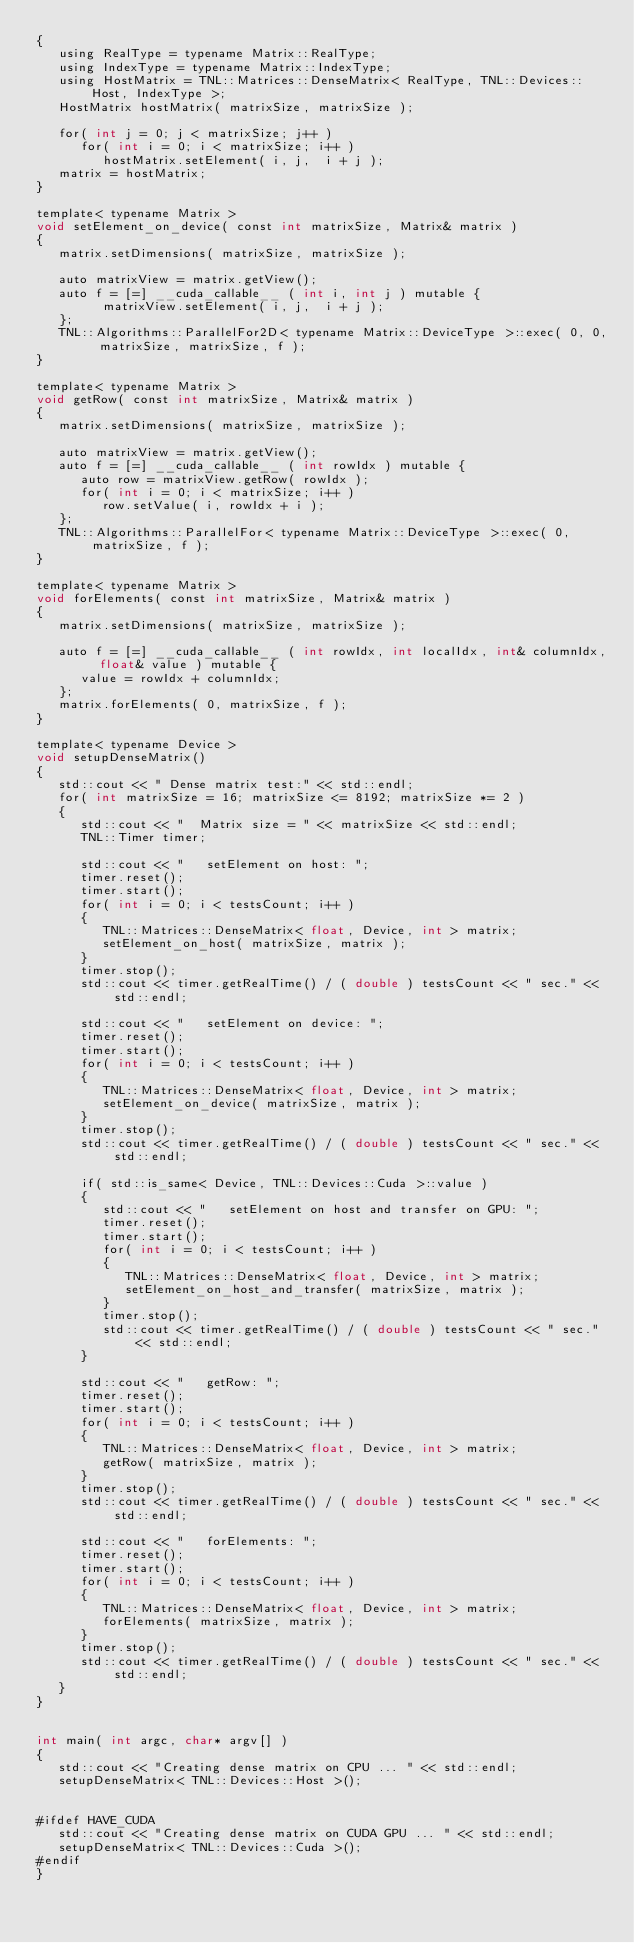<code> <loc_0><loc_0><loc_500><loc_500><_Cuda_>{
   using RealType = typename Matrix::RealType;
   using IndexType = typename Matrix::IndexType;
   using HostMatrix = TNL::Matrices::DenseMatrix< RealType, TNL::Devices::Host, IndexType >;
   HostMatrix hostMatrix( matrixSize, matrixSize );

   for( int j = 0; j < matrixSize; j++ )
      for( int i = 0; i < matrixSize; i++ )
         hostMatrix.setElement( i, j,  i + j );
   matrix = hostMatrix;
}

template< typename Matrix >
void setElement_on_device( const int matrixSize, Matrix& matrix )
{
   matrix.setDimensions( matrixSize, matrixSize );

   auto matrixView = matrix.getView();
   auto f = [=] __cuda_callable__ ( int i, int j ) mutable {
         matrixView.setElement( i, j,  i + j );
   };
   TNL::Algorithms::ParallelFor2D< typename Matrix::DeviceType >::exec( 0, 0, matrixSize, matrixSize, f );
}

template< typename Matrix >
void getRow( const int matrixSize, Matrix& matrix )
{
   matrix.setDimensions( matrixSize, matrixSize );

   auto matrixView = matrix.getView();
   auto f = [=] __cuda_callable__ ( int rowIdx ) mutable {
      auto row = matrixView.getRow( rowIdx );
      for( int i = 0; i < matrixSize; i++ )
         row.setValue( i, rowIdx + i );
   };
   TNL::Algorithms::ParallelFor< typename Matrix::DeviceType >::exec( 0, matrixSize, f );
}

template< typename Matrix >
void forElements( const int matrixSize, Matrix& matrix )
{
   matrix.setDimensions( matrixSize, matrixSize );

   auto f = [=] __cuda_callable__ ( int rowIdx, int localIdx, int& columnIdx, float& value ) mutable {
      value = rowIdx + columnIdx;
   };
   matrix.forElements( 0, matrixSize, f );
}

template< typename Device >
void setupDenseMatrix()
{
   std::cout << " Dense matrix test:" << std::endl;
   for( int matrixSize = 16; matrixSize <= 8192; matrixSize *= 2 )
   {
      std::cout << "  Matrix size = " << matrixSize << std::endl;
      TNL::Timer timer;

      std::cout << "   setElement on host: ";
      timer.reset();
      timer.start();
      for( int i = 0; i < testsCount; i++ )
      {
         TNL::Matrices::DenseMatrix< float, Device, int > matrix;
         setElement_on_host( matrixSize, matrix );
      }
      timer.stop();
      std::cout << timer.getRealTime() / ( double ) testsCount << " sec." << std::endl;

      std::cout << "   setElement on device: ";
      timer.reset();
      timer.start();
      for( int i = 0; i < testsCount; i++ )
      {
         TNL::Matrices::DenseMatrix< float, Device, int > matrix;
         setElement_on_device( matrixSize, matrix );
      }
      timer.stop();
      std::cout << timer.getRealTime() / ( double ) testsCount << " sec." << std::endl;

      if( std::is_same< Device, TNL::Devices::Cuda >::value )
      {
         std::cout << "   setElement on host and transfer on GPU: ";
         timer.reset();
         timer.start();
         for( int i = 0; i < testsCount; i++ )
         {
            TNL::Matrices::DenseMatrix< float, Device, int > matrix;
            setElement_on_host_and_transfer( matrixSize, matrix );
         }
         timer.stop();
         std::cout << timer.getRealTime() / ( double ) testsCount << " sec." << std::endl;
      }

      std::cout << "   getRow: ";
      timer.reset();
      timer.start();
      for( int i = 0; i < testsCount; i++ )
      {
         TNL::Matrices::DenseMatrix< float, Device, int > matrix;
         getRow( matrixSize, matrix );
      }
      timer.stop();
      std::cout << timer.getRealTime() / ( double ) testsCount << " sec." << std::endl;

      std::cout << "   forElements: ";
      timer.reset();
      timer.start();
      for( int i = 0; i < testsCount; i++ )
      {
         TNL::Matrices::DenseMatrix< float, Device, int > matrix;
         forElements( matrixSize, matrix );
      }
      timer.stop();
      std::cout << timer.getRealTime() / ( double ) testsCount << " sec." << std::endl;
   }
}


int main( int argc, char* argv[] )
{
   std::cout << "Creating dense matrix on CPU ... " << std::endl;
   setupDenseMatrix< TNL::Devices::Host >();


#ifdef HAVE_CUDA
   std::cout << "Creating dense matrix on CUDA GPU ... " << std::endl;
   setupDenseMatrix< TNL::Devices::Cuda >();
#endif
}
</code> 